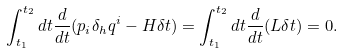Convert formula to latex. <formula><loc_0><loc_0><loc_500><loc_500>\int _ { t _ { 1 } } ^ { t _ { 2 } } d t \frac { d } { d t } ( p _ { i } \delta _ { h } q ^ { i } - { H } \delta t ) = \int _ { t _ { 1 } } ^ { t _ { 2 } } d t \frac { d } { d t } ( { L } \delta t ) = 0 .</formula> 